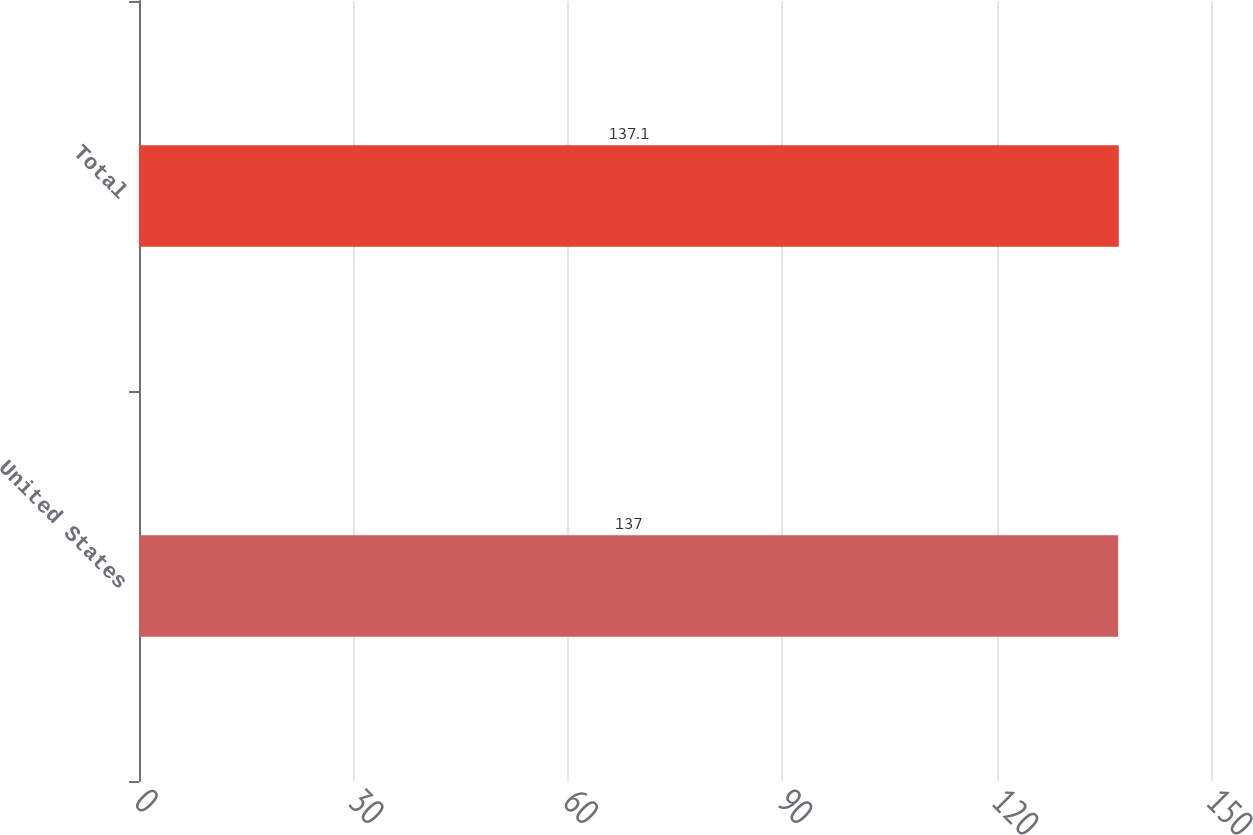Convert chart to OTSL. <chart><loc_0><loc_0><loc_500><loc_500><bar_chart><fcel>United States<fcel>Total<nl><fcel>137<fcel>137.1<nl></chart> 